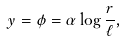<formula> <loc_0><loc_0><loc_500><loc_500>y = \phi = \alpha \log \frac { r } { \ell } ,</formula> 